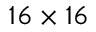Convert formula to latex. <formula><loc_0><loc_0><loc_500><loc_500>1 6 \times 1 6</formula> 